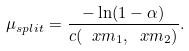Convert formula to latex. <formula><loc_0><loc_0><loc_500><loc_500>\mu _ { s p l i t } = \frac { - \ln ( 1 - \alpha ) } { c ( \ x m _ { 1 } , \ x m _ { 2 } ) } .</formula> 